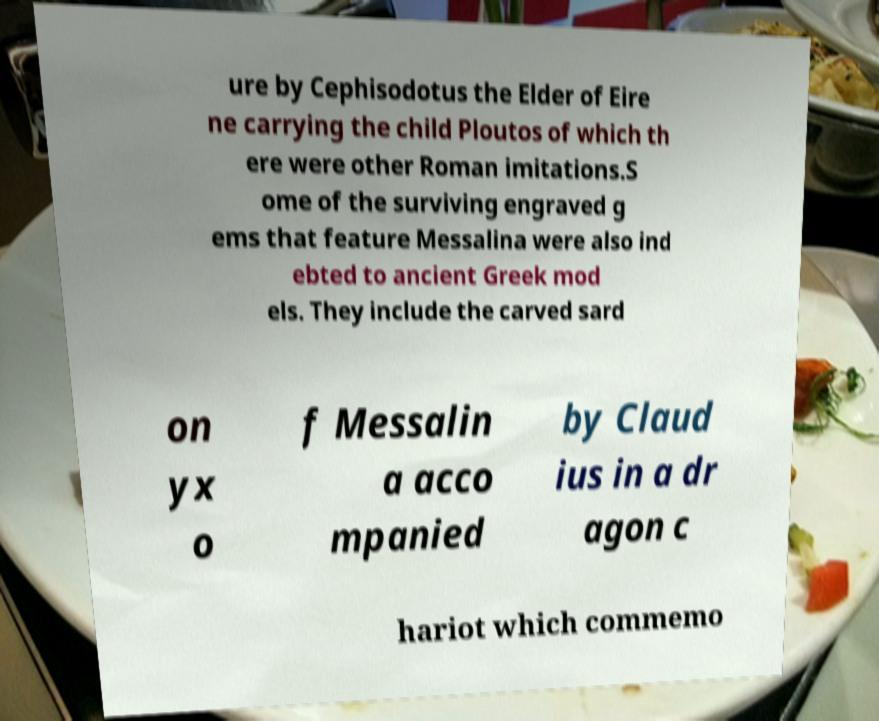Please read and relay the text visible in this image. What does it say? ure by Cephisodotus the Elder of Eire ne carrying the child Ploutos of which th ere were other Roman imitations.S ome of the surviving engraved g ems that feature Messalina were also ind ebted to ancient Greek mod els. They include the carved sard on yx o f Messalin a acco mpanied by Claud ius in a dr agon c hariot which commemo 